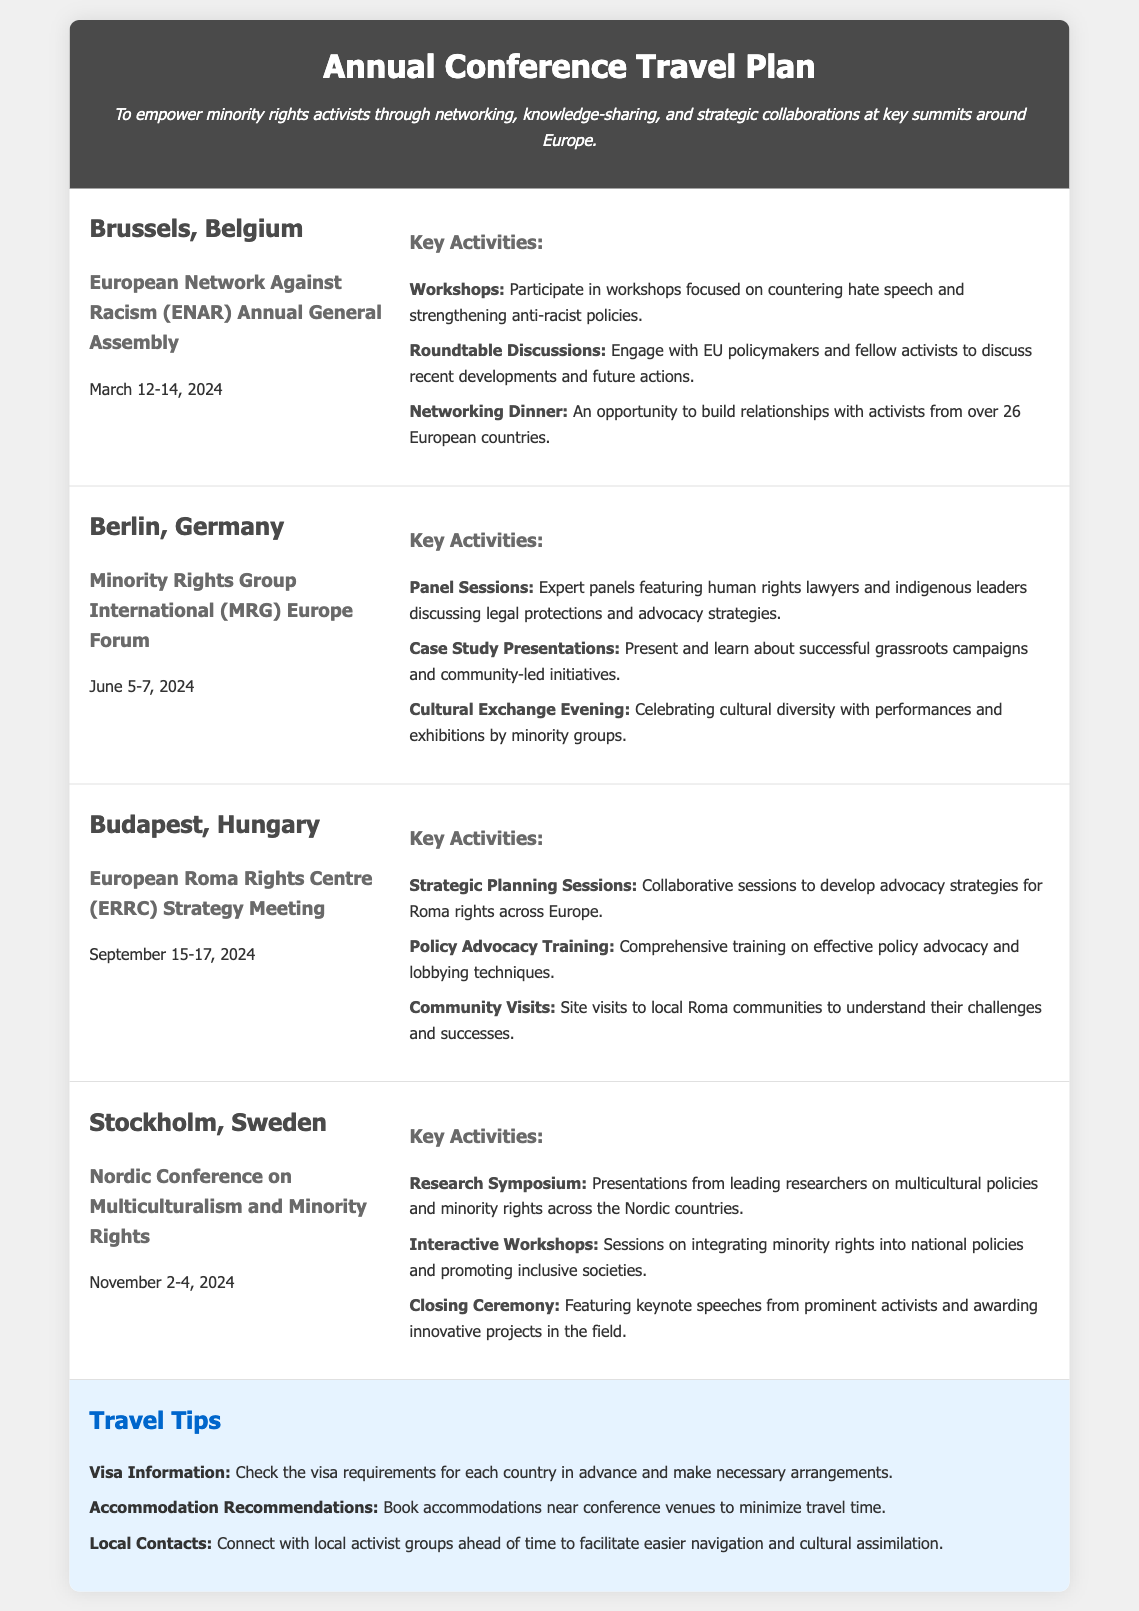What is the location of the first conference? The first conference is located in Brussels, Belgium.
Answer: Brussels, Belgium What are the dates for the MRG Europe Forum? The MRG Europe Forum is scheduled for June 5-7, 2024.
Answer: June 5-7, 2024 What type of activity will be held during the ERRC Strategy Meeting? The ERRC Strategy Meeting will feature strategic planning sessions for advocacy strategies.
Answer: Strategic Planning Sessions How many countries will activists network with at the ENAR Annual General Assembly? Activists will network with activists from over 26 European countries at the ENAR assembly.
Answer: 26 What is a key activity in Stockholm? A key activity in Stockholm is the research symposium on multicultural policies.
Answer: Research Symposium Name one of the travel tips provided in the document. One travel tip is to check the visa requirements for each country in advance.
Answer: Check visa requirements What is the focus of the workshops at the ENAR Annual General Assembly? The workshops at the ENAR assembly focus on countering hate speech and strengthening anti-racist policies.
Answer: Countering hate speech When is the Nordic Conference on Multiculturalism and Minority Rights taking place? The Nordic Conference is taking place on November 2-4, 2024.
Answer: November 2-4, 2024 